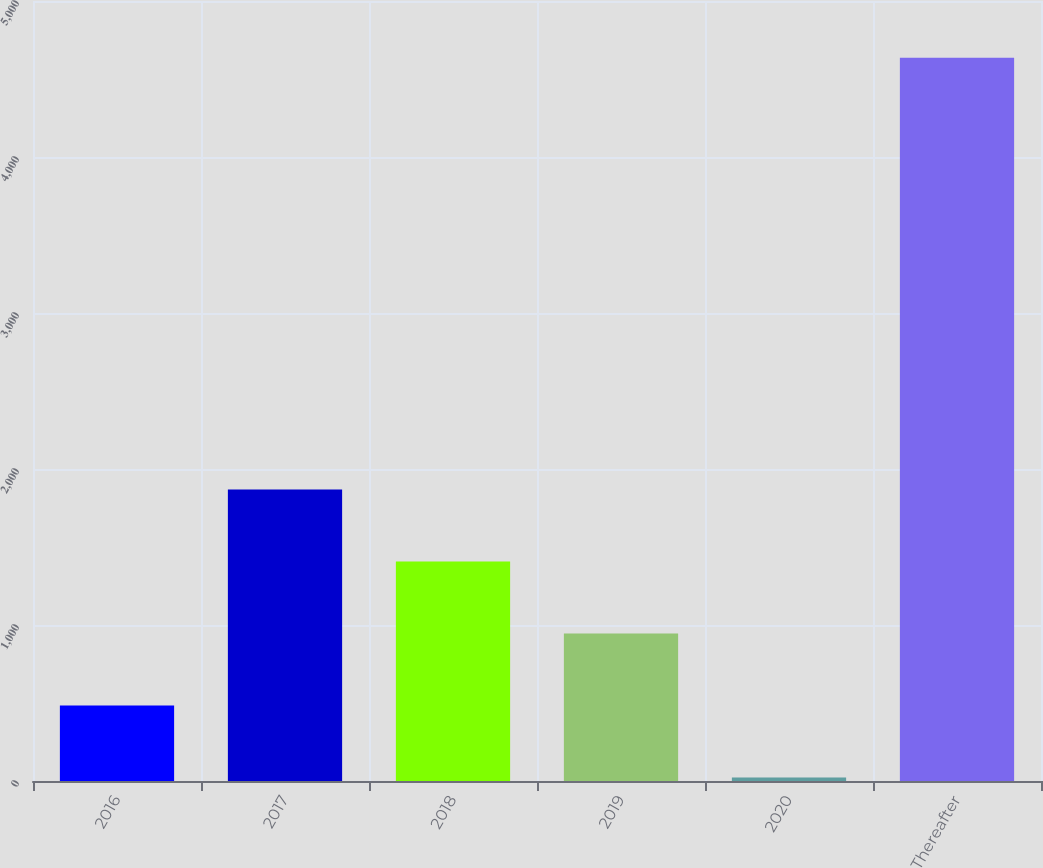Convert chart to OTSL. <chart><loc_0><loc_0><loc_500><loc_500><bar_chart><fcel>2016<fcel>2017<fcel>2018<fcel>2019<fcel>2020<fcel>Thereafter<nl><fcel>483.5<fcel>1868<fcel>1406.5<fcel>945<fcel>22<fcel>4637<nl></chart> 